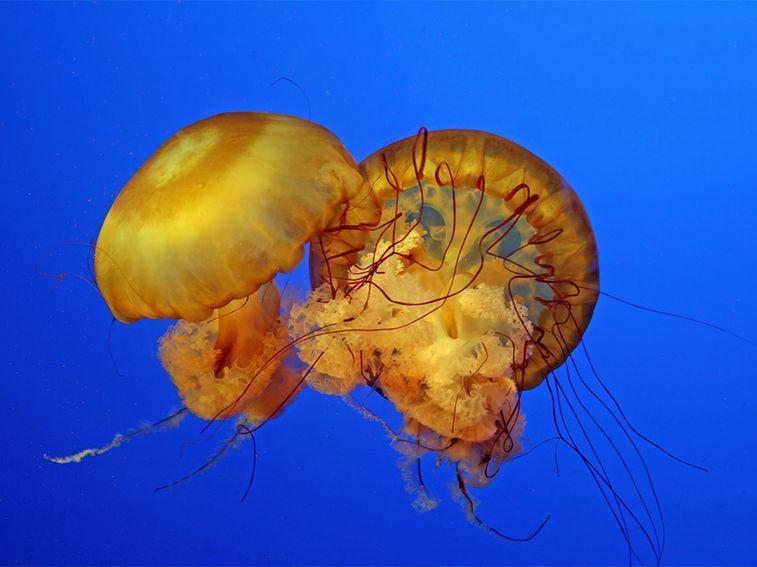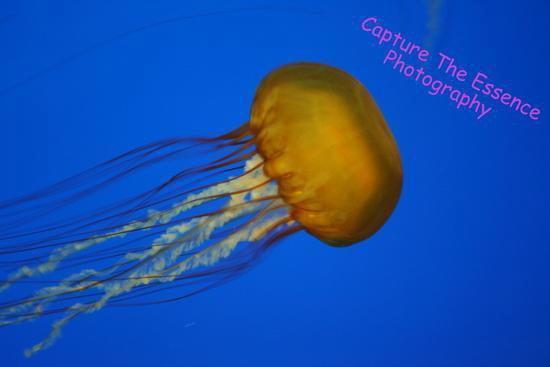The first image is the image on the left, the second image is the image on the right. Evaluate the accuracy of this statement regarding the images: "There are a total of three jellyfish.". Is it true? Answer yes or no. Yes. 